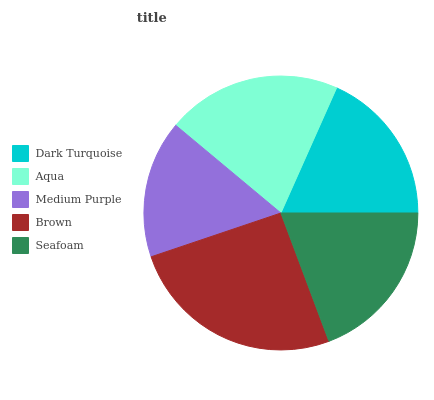Is Medium Purple the minimum?
Answer yes or no. Yes. Is Brown the maximum?
Answer yes or no. Yes. Is Aqua the minimum?
Answer yes or no. No. Is Aqua the maximum?
Answer yes or no. No. Is Aqua greater than Dark Turquoise?
Answer yes or no. Yes. Is Dark Turquoise less than Aqua?
Answer yes or no. Yes. Is Dark Turquoise greater than Aqua?
Answer yes or no. No. Is Aqua less than Dark Turquoise?
Answer yes or no. No. Is Seafoam the high median?
Answer yes or no. Yes. Is Seafoam the low median?
Answer yes or no. Yes. Is Aqua the high median?
Answer yes or no. No. Is Brown the low median?
Answer yes or no. No. 